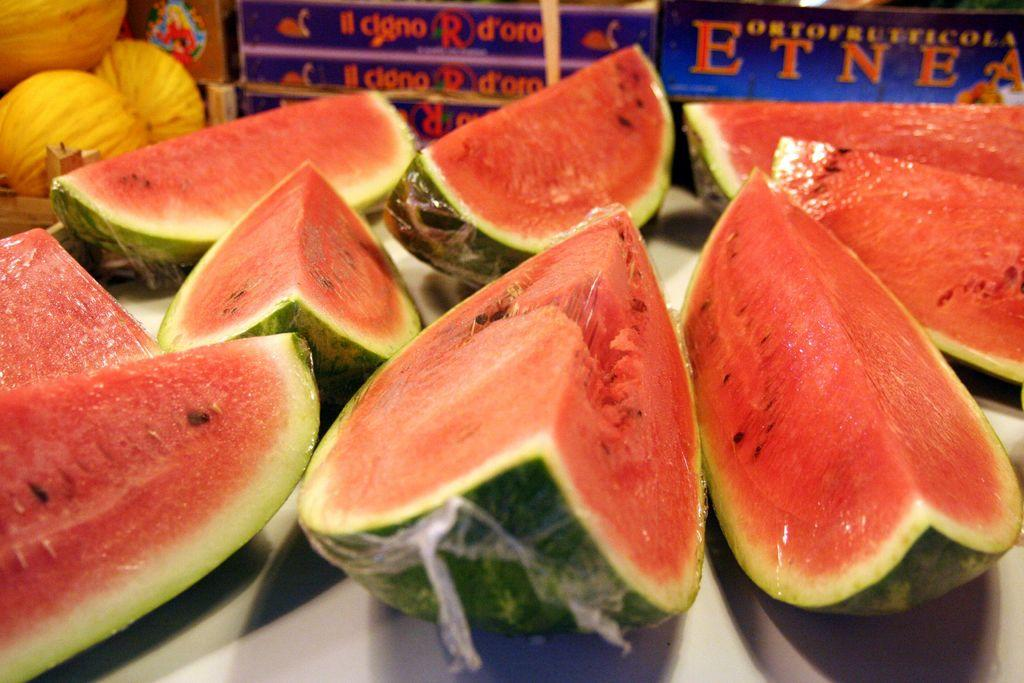What type of objects are present in the image? There are food items in the image. Can you describe any other elements in the image besides the food items? Yes, there is text written in the image, presumably behind the food items. How many books are stacked on the faucet in the image? There are no books or faucets present in the image. What type of song is being sung by the person in the image? There is no person or song present in the image. 